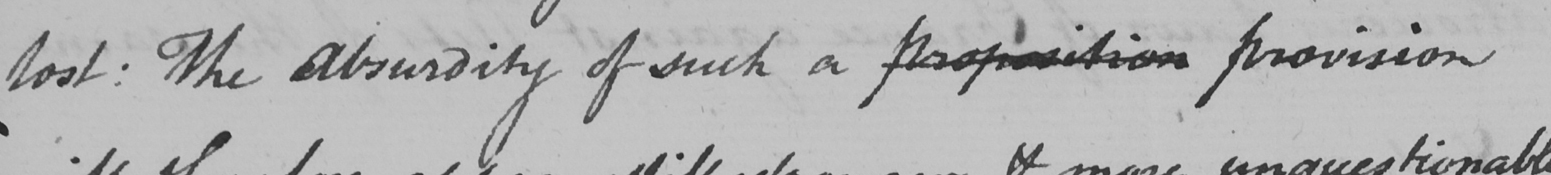Please provide the text content of this handwritten line. lost :  The Absurdity of such a proposition provision 